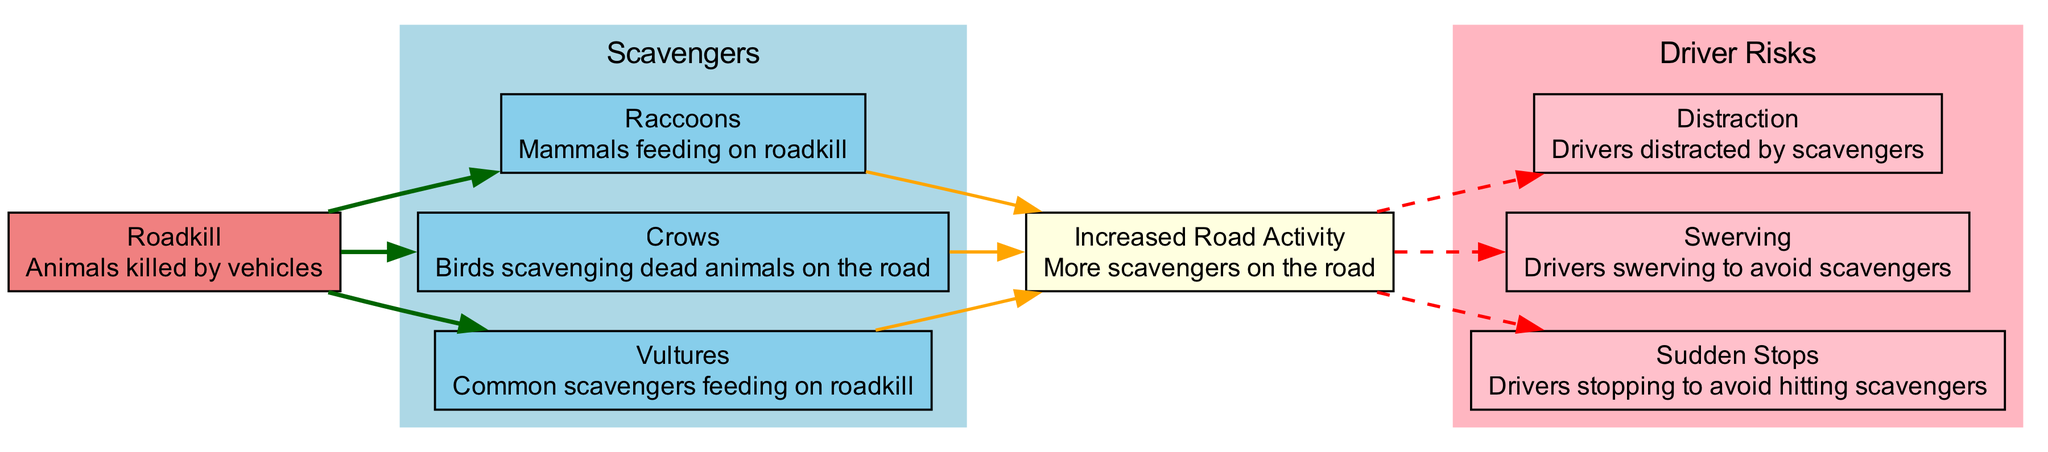What animal group primarily feeds on roadkill? The diagram lists scavengers as the group feeding on roadkill, which includes sub-elements such as vultures, crows, and raccoons. Thus, "scavengers" is the correct group.
Answer: scavengers How many sub-elements are included under Scavengers? The scavenger section shows three specific types of animals: vultures, crows, and raccoons. Counting these gives a total of three sub-elements.
Answer: 3 What is one behavioral risk associated with increased road activity? The diagram identifies “sudden stops,” “swerving,” and “distraction” as risks. Any of these would suffice, but choosing one, "sudden stops" is a direct, accurate response.
Answer: sudden stops Which scavenger type is categorized specifically as mammalian? Among the sub-elements listed under scavengers, "raccoons" is specifically identified as a mammal. Therefore, the answer is clear from the diagram.
Answer: raccoons What type of relationship connects Roadkill to Increased Road Activity? The edge connecting these two nodes illustrates that roadkill contributes to increased road activity by providing food for the scavengers, thus linking them. This is a direct cause-and-effect relationship represented visually.
Answer: cause-and-effect Are all driver risks connected to scavenger species? Assessing the diagram shows that increased road activity, which is influenced by scavengers, leads to driver risks. Hence, all risks indirectly relate to scavengers through this connection.
Answer: yes How many types of driver risks are mentioned in the diagram? There are three types of driver risks noted: sudden stops, swerving, and distraction. A count reveals that there are precisely three distinct types detailed in the area.
Answer: 3 What color represents the "Driver Risks" section in the diagram? The diagram indicates that the "Driver Risks" section is filled with a light pink color. This visual cue differentiates it from other sections clearly.
Answer: light pink 